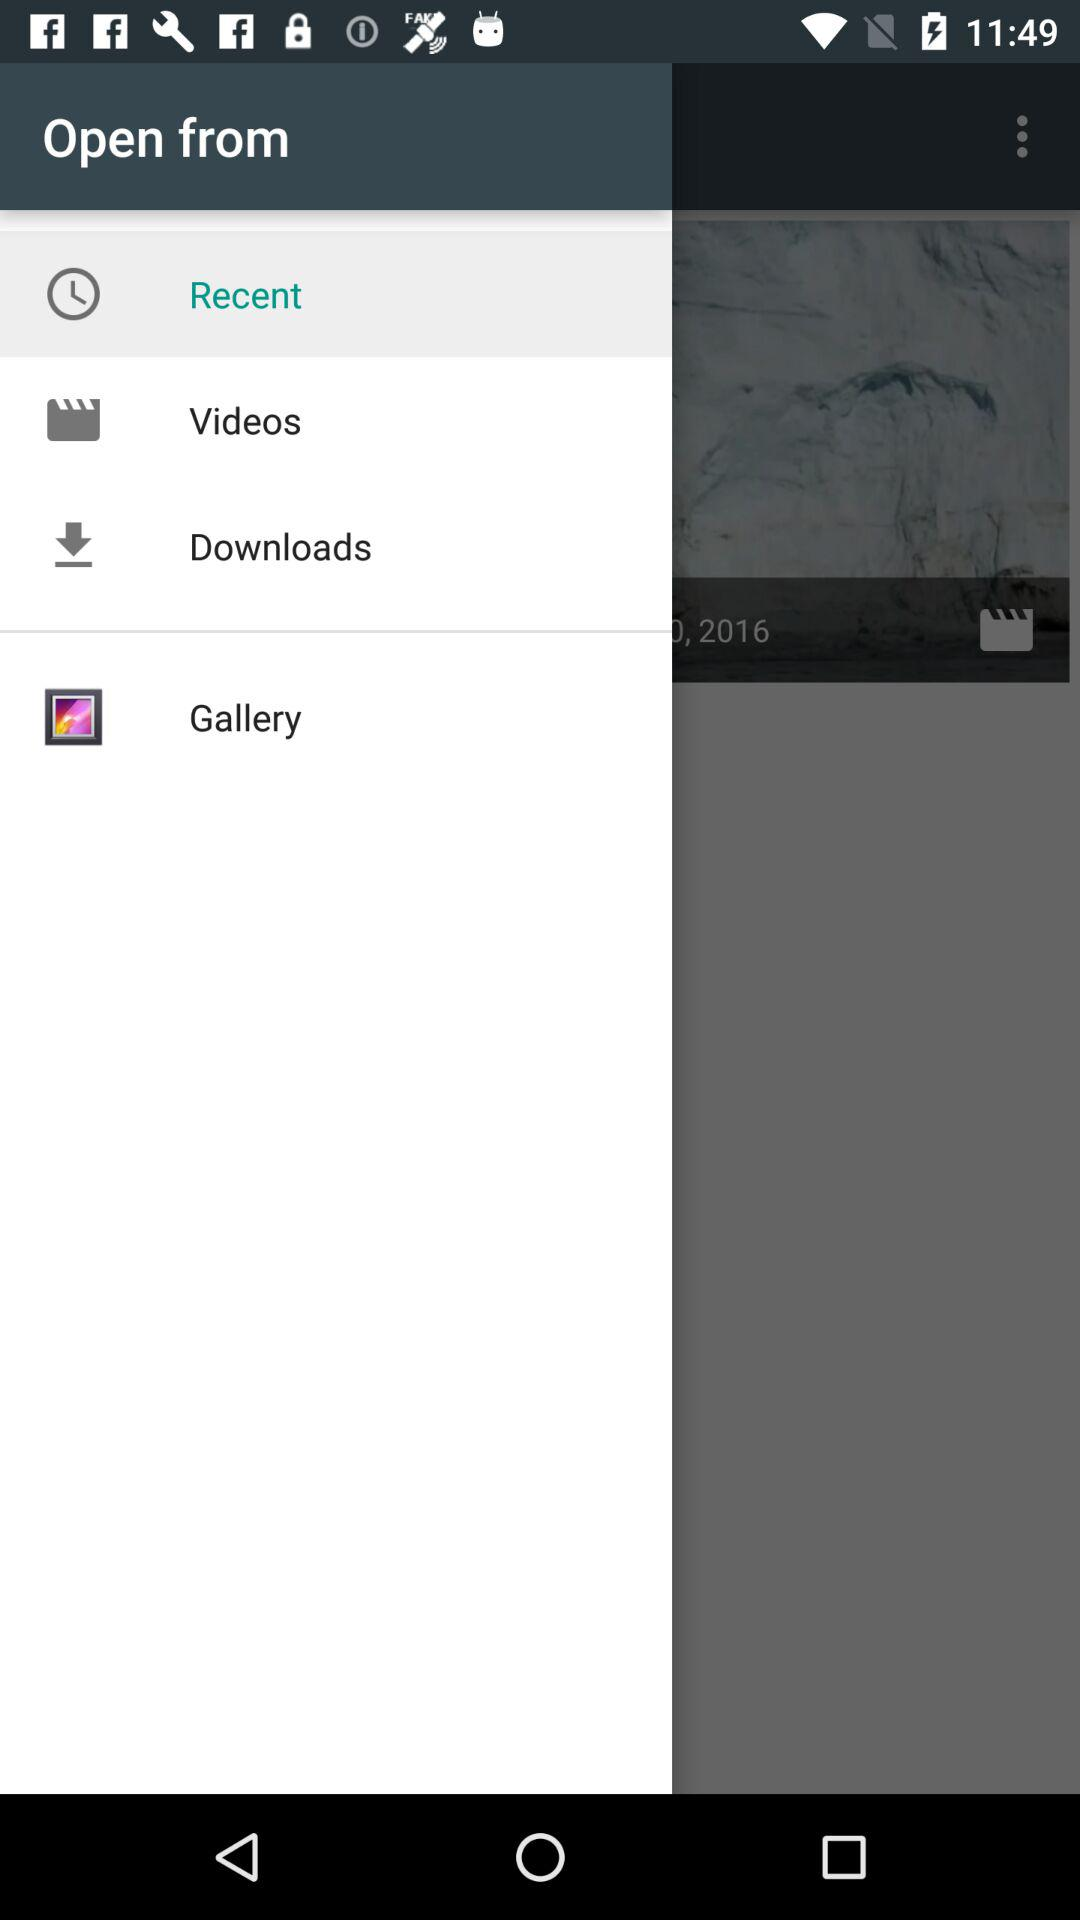How many items are in "Downloads"?
When the provided information is insufficient, respond with <no answer>. <no answer> 